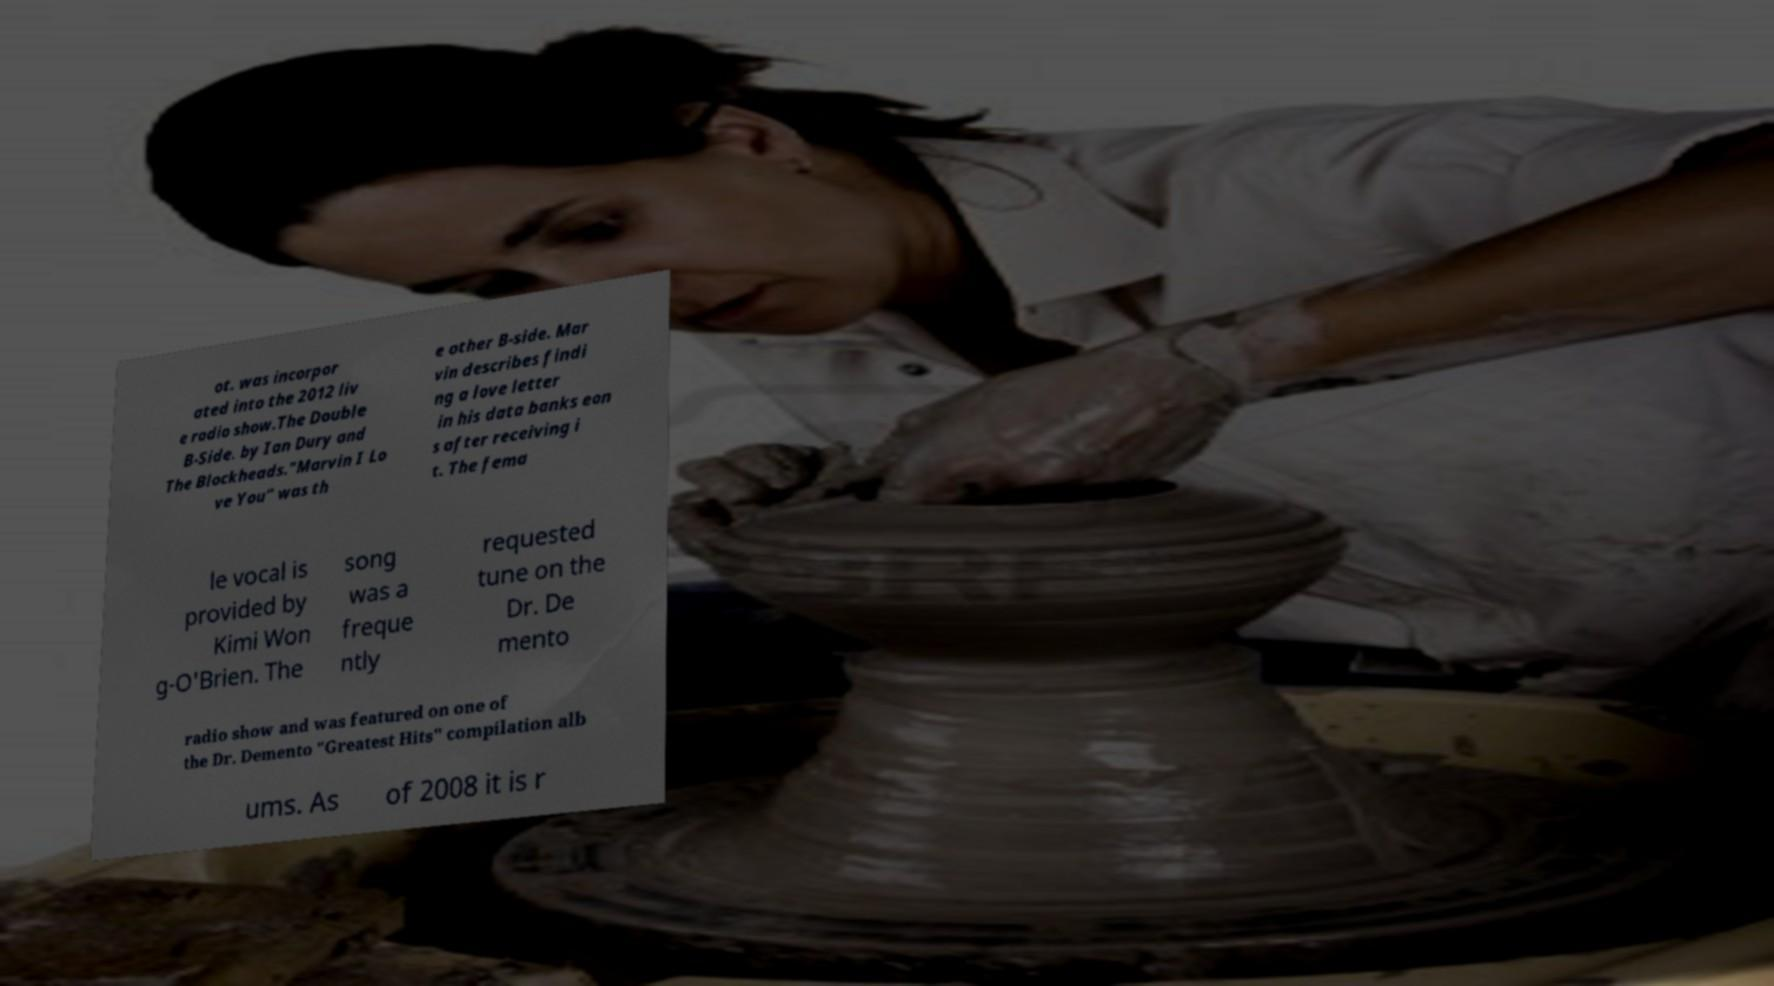Please identify and transcribe the text found in this image. ot. was incorpor ated into the 2012 liv e radio show.The Double B-Side. by Ian Dury and The Blockheads."Marvin I Lo ve You" was th e other B-side. Mar vin describes findi ng a love letter in his data banks eon s after receiving i t. The fema le vocal is provided by Kimi Won g-O'Brien. The song was a freque ntly requested tune on the Dr. De mento radio show and was featured on one of the Dr. Demento "Greatest Hits" compilation alb ums. As of 2008 it is r 